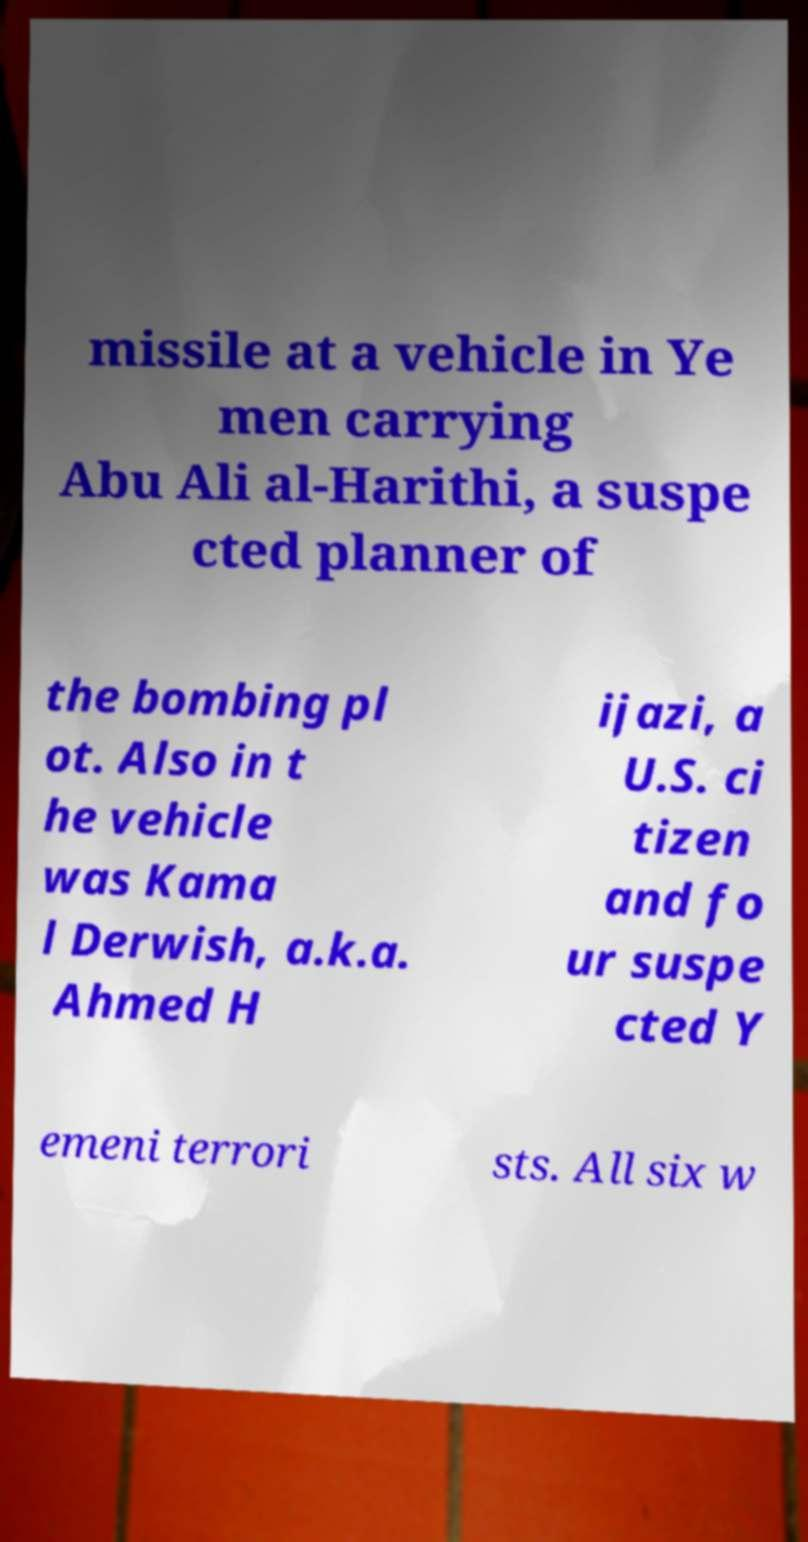For documentation purposes, I need the text within this image transcribed. Could you provide that? missile at a vehicle in Ye men carrying Abu Ali al-Harithi, a suspe cted planner of the bombing pl ot. Also in t he vehicle was Kama l Derwish, a.k.a. Ahmed H ijazi, a U.S. ci tizen and fo ur suspe cted Y emeni terrori sts. All six w 